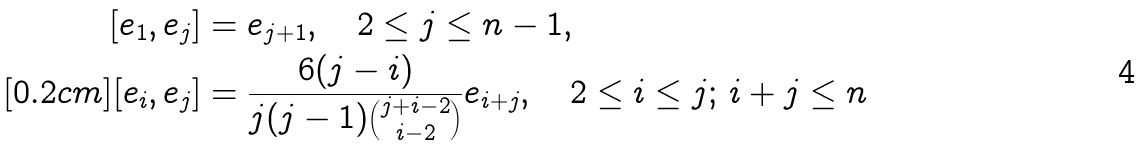Convert formula to latex. <formula><loc_0><loc_0><loc_500><loc_500>[ e _ { 1 } , e _ { j } ] & = e _ { j + 1 } , \quad 2 \leq j \leq n - 1 , \\ [ 0 . 2 c m ] [ e _ { i } , e _ { j } ] & = \frac { 6 ( j - i ) } { j ( j - 1 ) \binom { j + i - 2 } { i - 2 } } e _ { i + j } , \quad 2 \leq i \leq j ; \, i + j \leq n</formula> 